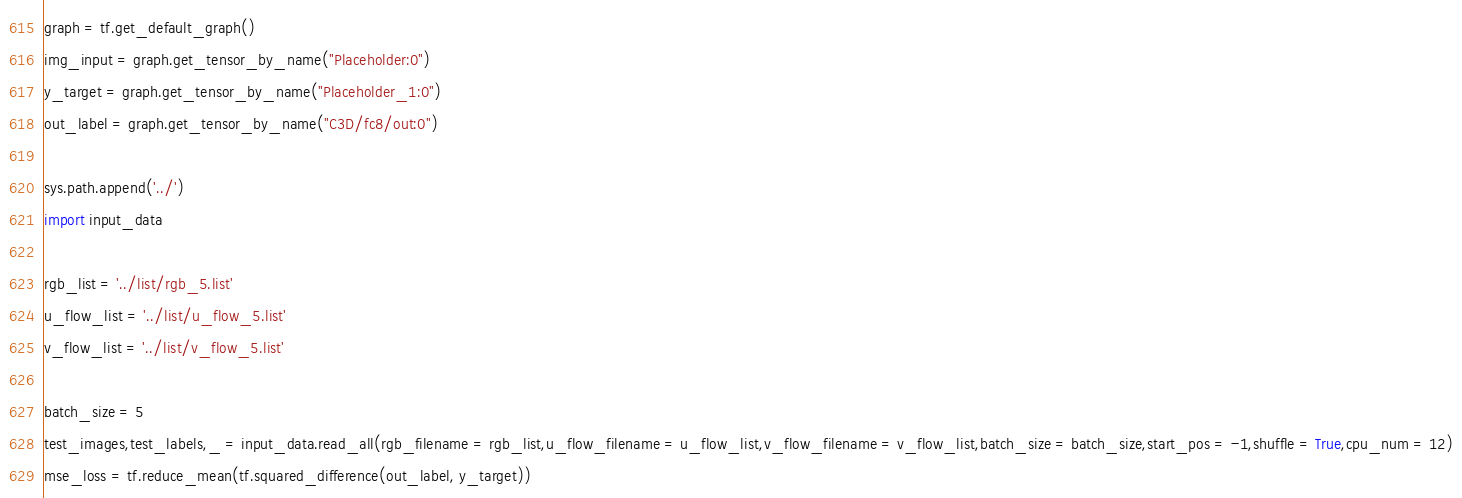<code> <loc_0><loc_0><loc_500><loc_500><_Python_>
graph = tf.get_default_graph()
img_input = graph.get_tensor_by_name("Placeholder:0")
y_target = graph.get_tensor_by_name("Placeholder_1:0")
out_label = graph.get_tensor_by_name("C3D/fc8/out:0")

sys.path.append('../')
import input_data

rgb_list = '../list/rgb_5.list'
u_flow_list = '../list/u_flow_5.list'
v_flow_list = '../list/v_flow_5.list'

batch_size = 5
test_images,test_labels,_ = input_data.read_all(rgb_filename = rgb_list,u_flow_filename = u_flow_list,v_flow_filename = v_flow_list,batch_size = batch_size,start_pos = -1,shuffle = True,cpu_num = 12)
mse_loss = tf.reduce_mean(tf.squared_difference(out_label, y_target))</code> 